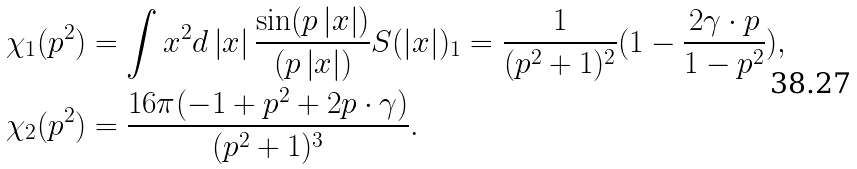Convert formula to latex. <formula><loc_0><loc_0><loc_500><loc_500>\chi _ { 1 } ( p ^ { 2 } ) & = \int x ^ { 2 } d \left | x \right | \frac { \sin ( p \left | x \right | ) } { ( p \left | x \right | ) } S ( \left | x \right | ) _ { 1 } = \frac { 1 } { ( p ^ { 2 } + 1 ) ^ { 2 } } ( 1 - \frac { 2 \gamma \cdot p } { 1 - p ^ { 2 } } ) , \\ \chi _ { 2 } ( p ^ { 2 } ) & = \frac { 1 6 \pi ( - 1 + p ^ { 2 } + 2 p \cdot \gamma ) } { ( p ^ { 2 } + 1 ) ^ { 3 } } .</formula> 